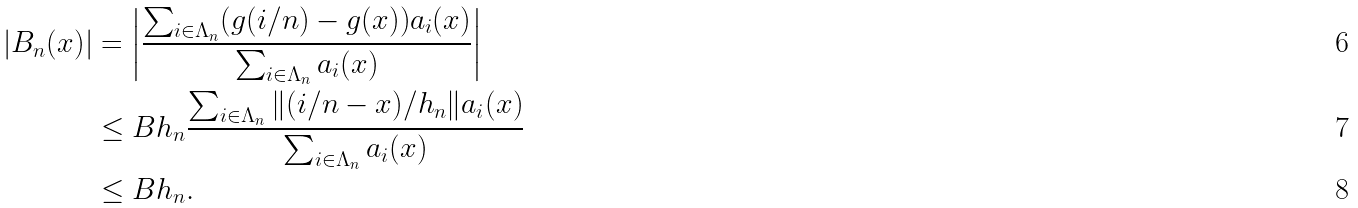<formula> <loc_0><loc_0><loc_500><loc_500>| B _ { n } ( x ) | & = \left | \frac { \sum _ { i \in \Lambda _ { n } } ( g ( i / n ) - g ( x ) ) a _ { i } ( x ) } { \sum _ { i \in \Lambda _ { n } } a _ { i } ( x ) } \right | \\ & \leq B h _ { n } \frac { \sum _ { i \in \Lambda _ { n } } \| ( i / n - x ) / h _ { n } \| a _ { i } ( x ) } { \sum _ { i \in \Lambda _ { n } } a _ { i } ( x ) } \\ & \leq B h _ { n } .</formula> 